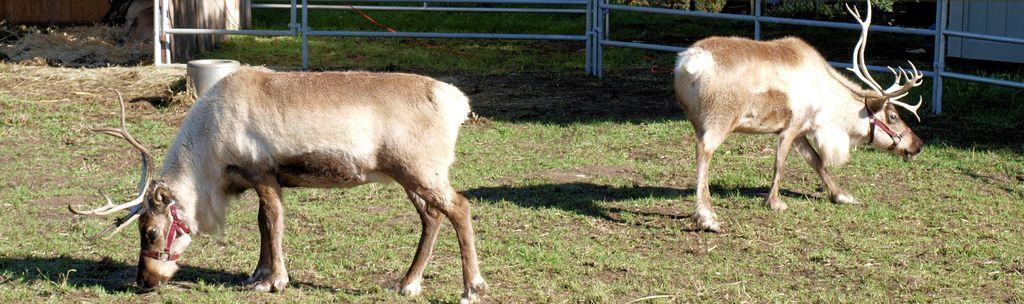How would you summarize this image in a sentence or two? In this image there are two wild deers are standing , and in the background there are iron rods, grass, plants. 